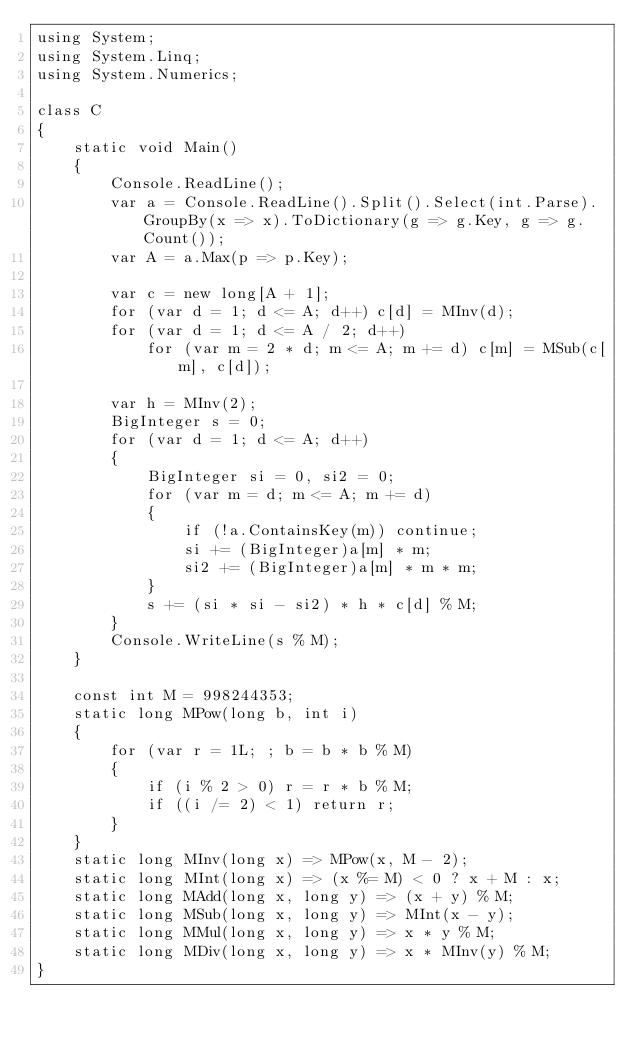<code> <loc_0><loc_0><loc_500><loc_500><_C#_>using System;
using System.Linq;
using System.Numerics;

class C
{
	static void Main()
	{
		Console.ReadLine();
		var a = Console.ReadLine().Split().Select(int.Parse).GroupBy(x => x).ToDictionary(g => g.Key, g => g.Count());
		var A = a.Max(p => p.Key);

		var c = new long[A + 1];
		for (var d = 1; d <= A; d++) c[d] = MInv(d);
		for (var d = 1; d <= A / 2; d++)
			for (var m = 2 * d; m <= A; m += d) c[m] = MSub(c[m], c[d]);

		var h = MInv(2);
		BigInteger s = 0;
		for (var d = 1; d <= A; d++)
		{
			BigInteger si = 0, si2 = 0;
			for (var m = d; m <= A; m += d)
			{
				if (!a.ContainsKey(m)) continue;
				si += (BigInteger)a[m] * m;
				si2 += (BigInteger)a[m] * m * m;
			}
			s += (si * si - si2) * h * c[d] % M;
		}
		Console.WriteLine(s % M);
	}

	const int M = 998244353;
	static long MPow(long b, int i)
	{
		for (var r = 1L; ; b = b * b % M)
		{
			if (i % 2 > 0) r = r * b % M;
			if ((i /= 2) < 1) return r;
		}
	}
	static long MInv(long x) => MPow(x, M - 2);
	static long MInt(long x) => (x %= M) < 0 ? x + M : x;
	static long MAdd(long x, long y) => (x + y) % M;
	static long MSub(long x, long y) => MInt(x - y);
	static long MMul(long x, long y) => x * y % M;
	static long MDiv(long x, long y) => x * MInv(y) % M;
}
</code> 